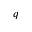<formula> <loc_0><loc_0><loc_500><loc_500>q</formula> 